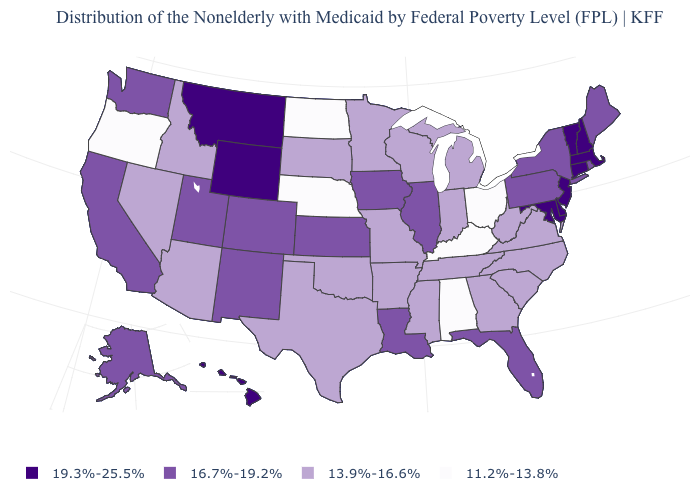Name the states that have a value in the range 13.9%-16.6%?
Answer briefly. Arizona, Arkansas, Georgia, Idaho, Indiana, Michigan, Minnesota, Mississippi, Missouri, Nevada, North Carolina, Oklahoma, South Carolina, South Dakota, Tennessee, Texas, Virginia, West Virginia, Wisconsin. What is the value of Massachusetts?
Write a very short answer. 19.3%-25.5%. Among the states that border Vermont , which have the lowest value?
Be succinct. New York. What is the value of Arizona?
Be succinct. 13.9%-16.6%. What is the lowest value in the South?
Short answer required. 11.2%-13.8%. Name the states that have a value in the range 19.3%-25.5%?
Quick response, please. Connecticut, Delaware, Hawaii, Maryland, Massachusetts, Montana, New Hampshire, New Jersey, Vermont, Wyoming. What is the lowest value in states that border Texas?
Answer briefly. 13.9%-16.6%. What is the lowest value in states that border South Carolina?
Give a very brief answer. 13.9%-16.6%. Name the states that have a value in the range 16.7%-19.2%?
Short answer required. Alaska, California, Colorado, Florida, Illinois, Iowa, Kansas, Louisiana, Maine, New Mexico, New York, Pennsylvania, Rhode Island, Utah, Washington. What is the value of Mississippi?
Concise answer only. 13.9%-16.6%. What is the lowest value in states that border Arkansas?
Answer briefly. 13.9%-16.6%. Name the states that have a value in the range 16.7%-19.2%?
Quick response, please. Alaska, California, Colorado, Florida, Illinois, Iowa, Kansas, Louisiana, Maine, New Mexico, New York, Pennsylvania, Rhode Island, Utah, Washington. What is the value of Indiana?
Short answer required. 13.9%-16.6%. Name the states that have a value in the range 19.3%-25.5%?
Be succinct. Connecticut, Delaware, Hawaii, Maryland, Massachusetts, Montana, New Hampshire, New Jersey, Vermont, Wyoming. Among the states that border New York , does New Jersey have the highest value?
Concise answer only. Yes. 